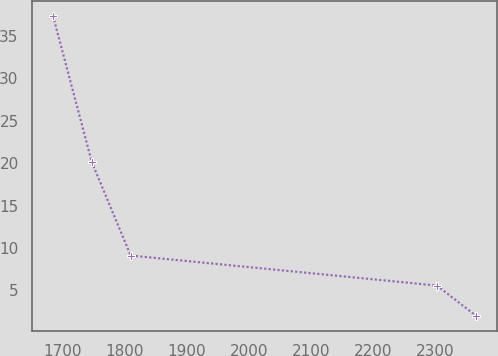Convert chart. <chart><loc_0><loc_0><loc_500><loc_500><line_chart><ecel><fcel>Unnamed: 1<nl><fcel>1685.3<fcel>37.39<nl><fcel>1747.72<fcel>20.12<nl><fcel>1810.14<fcel>9.12<nl><fcel>2302.06<fcel>5.58<nl><fcel>2364.48<fcel>2.04<nl></chart> 